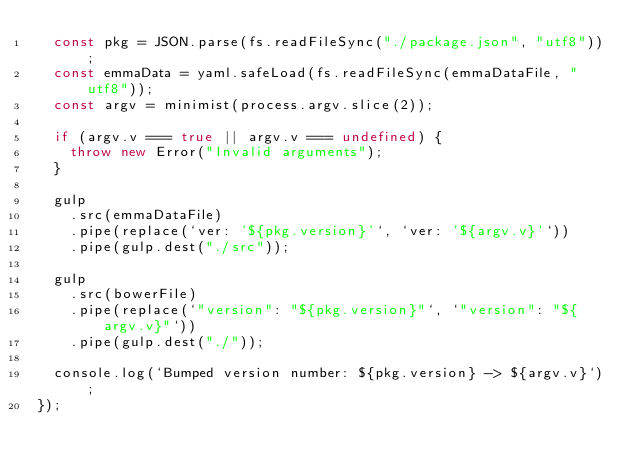<code> <loc_0><loc_0><loc_500><loc_500><_JavaScript_>  const pkg = JSON.parse(fs.readFileSync("./package.json", "utf8"));
  const emmaData = yaml.safeLoad(fs.readFileSync(emmaDataFile, "utf8"));
  const argv = minimist(process.argv.slice(2));

  if (argv.v === true || argv.v === undefined) {
    throw new Error("Invalid arguments");
  }

  gulp
    .src(emmaDataFile)
    .pipe(replace(`ver: '${pkg.version}'`, `ver: '${argv.v}'`))
    .pipe(gulp.dest("./src"));

  gulp
    .src(bowerFile)
    .pipe(replace(`"version": "${pkg.version}"`, `"version": "${argv.v}"`))
    .pipe(gulp.dest("./"));

  console.log(`Bumped version number: ${pkg.version} -> ${argv.v}`);
});
</code> 